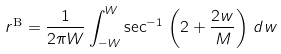<formula> <loc_0><loc_0><loc_500><loc_500>r ^ { \text {B} } = \frac { 1 } { 2 \pi W } \int _ { - W } ^ { W } \sec ^ { - 1 } \, \left ( 2 + \frac { 2 w } { M } \right ) \, d w</formula> 